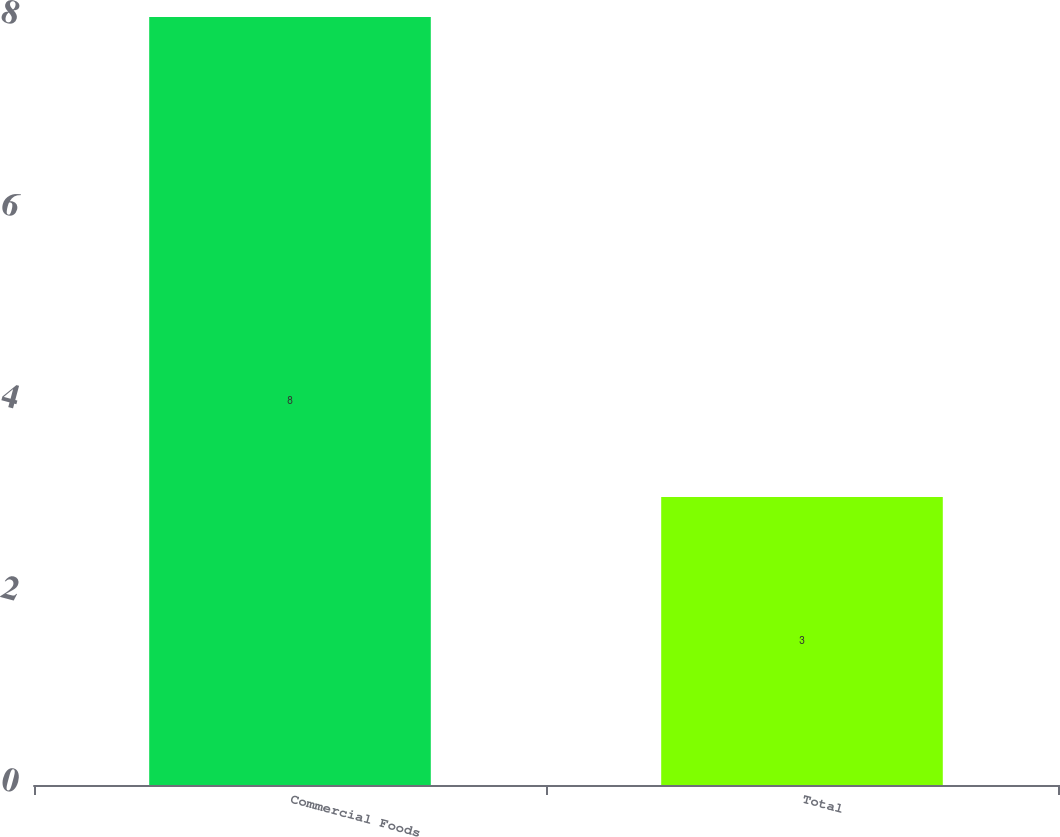<chart> <loc_0><loc_0><loc_500><loc_500><bar_chart><fcel>Commercial Foods<fcel>Total<nl><fcel>8<fcel>3<nl></chart> 